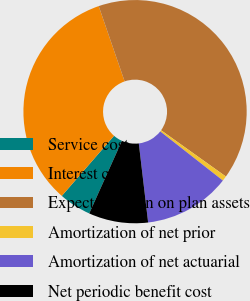<chart> <loc_0><loc_0><loc_500><loc_500><pie_chart><fcel>Service cost<fcel>Interest cost<fcel>Expected return on plan assets<fcel>Amortization of net prior<fcel>Amortization of net actuarial<fcel>Net periodic benefit cost<nl><fcel>4.66%<fcel>33.33%<fcel>40.14%<fcel>0.72%<fcel>12.54%<fcel>8.6%<nl></chart> 